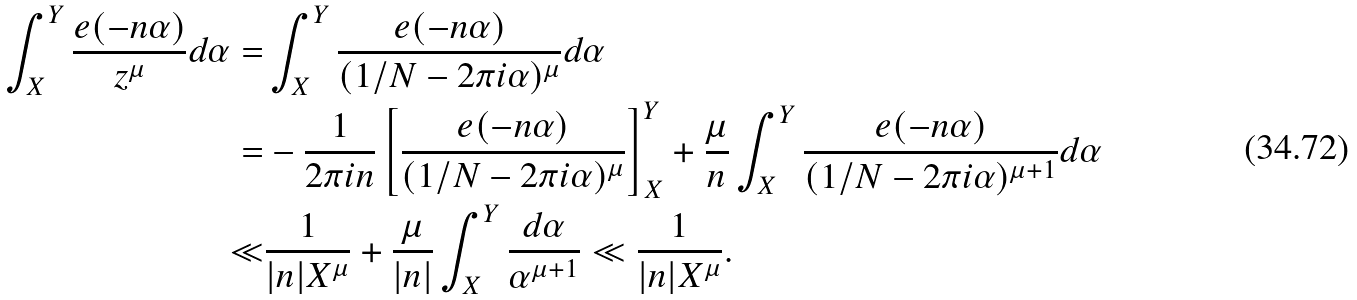Convert formula to latex. <formula><loc_0><loc_0><loc_500><loc_500>\int _ { X } ^ { Y } \frac { e ( - n \alpha ) } { z ^ { \mu } } d \alpha = & \int _ { X } ^ { Y } \frac { e ( - n \alpha ) } { ( 1 / N - 2 \pi i \alpha ) ^ { \mu } } d \alpha \\ = & - \frac { 1 } { 2 \pi i n } \left [ \frac { e ( - n \alpha ) } { ( 1 / N - 2 \pi i \alpha ) ^ { \mu } } \right ] _ { X } ^ { Y } + \frac { \mu } { n } \int _ { X } ^ { Y } \frac { e ( - n \alpha ) } { ( 1 / N - 2 \pi i \alpha ) ^ { \mu + 1 } } d \alpha \\ \ll & \frac { 1 } { | n | X ^ { \mu } } + \frac { \mu } { | n | } \int _ { X } ^ { Y } \frac { d \alpha } { \alpha ^ { \mu + 1 } } \ll \frac { 1 } { | n | X ^ { \mu } } .</formula> 